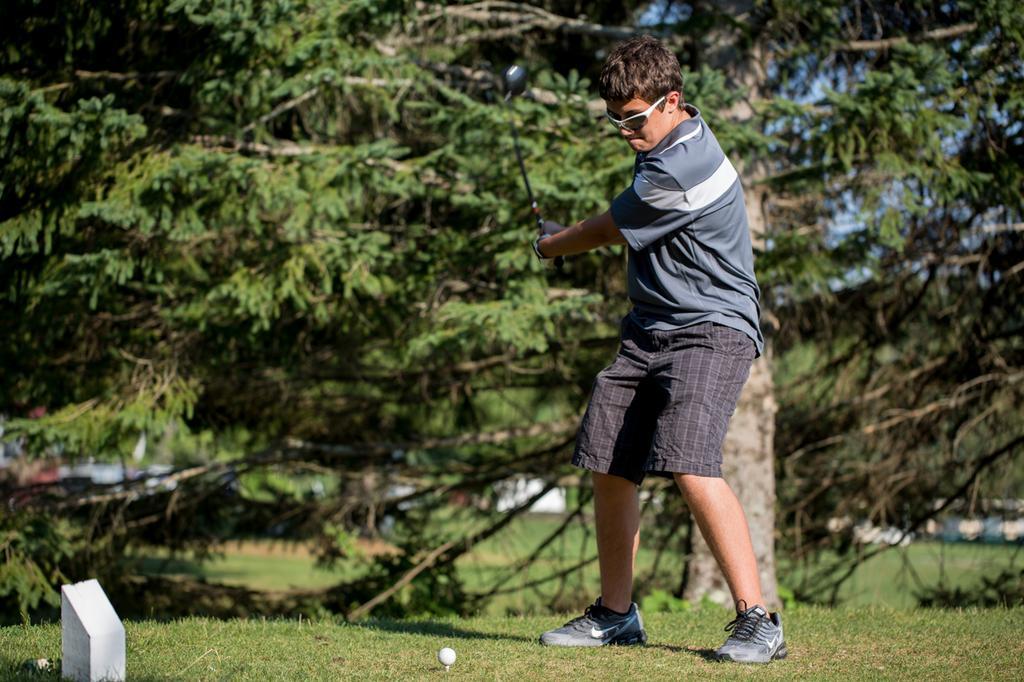Please provide a concise description of this image. In the center of the image there is a person playing golf. At the bottom of the image there is grass. There is a golf ball. In the background of the image there are trees. 